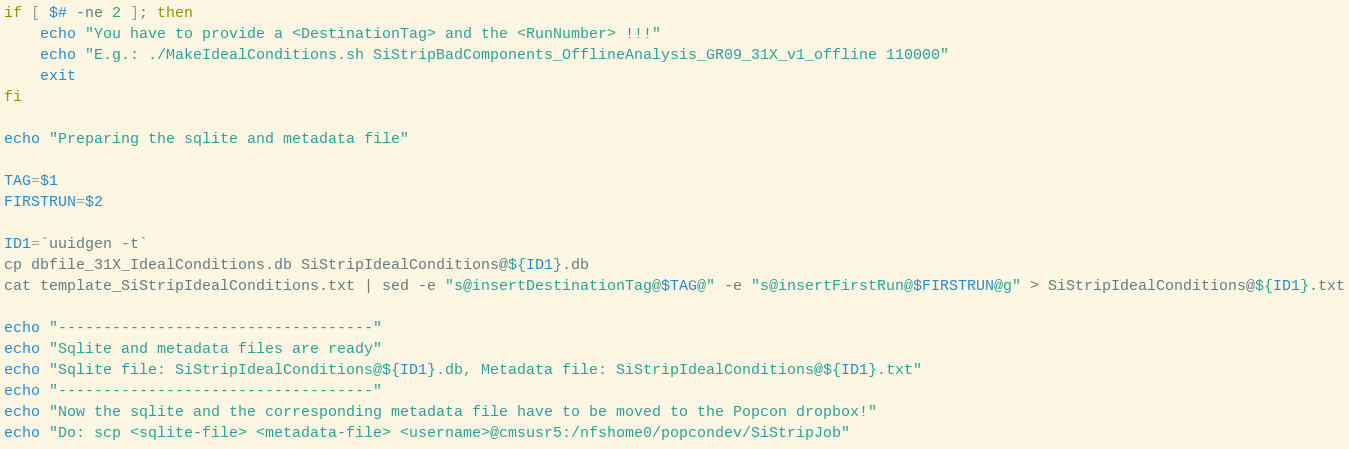Convert code to text. <code><loc_0><loc_0><loc_500><loc_500><_Bash_>if [ $# -ne 2 ]; then
    echo "You have to provide a <DestinationTag> and the <RunNumber> !!!"
    echo "E.g.: ./MakeIdealConditions.sh SiStripBadComponents_OfflineAnalysis_GR09_31X_v1_offline 110000"
    exit
fi

echo "Preparing the sqlite and metadata file"

TAG=$1
FIRSTRUN=$2

ID1=`uuidgen -t`
cp dbfile_31X_IdealConditions.db SiStripIdealConditions@${ID1}.db
cat template_SiStripIdealConditions.txt | sed -e "s@insertDestinationTag@$TAG@" -e "s@insertFirstRun@$FIRSTRUN@g" > SiStripIdealConditions@${ID1}.txt

echo "-----------------------------------"
echo "Sqlite and metadata files are ready"
echo "Sqlite file: SiStripIdealConditions@${ID1}.db, Metadata file: SiStripIdealConditions@${ID1}.txt"
echo "-----------------------------------"
echo "Now the sqlite and the corresponding metadata file have to be moved to the Popcon dropbox!"
echo "Do: scp <sqlite-file> <metadata-file> <username>@cmsusr5:/nfshome0/popcondev/SiStripJob"
</code> 